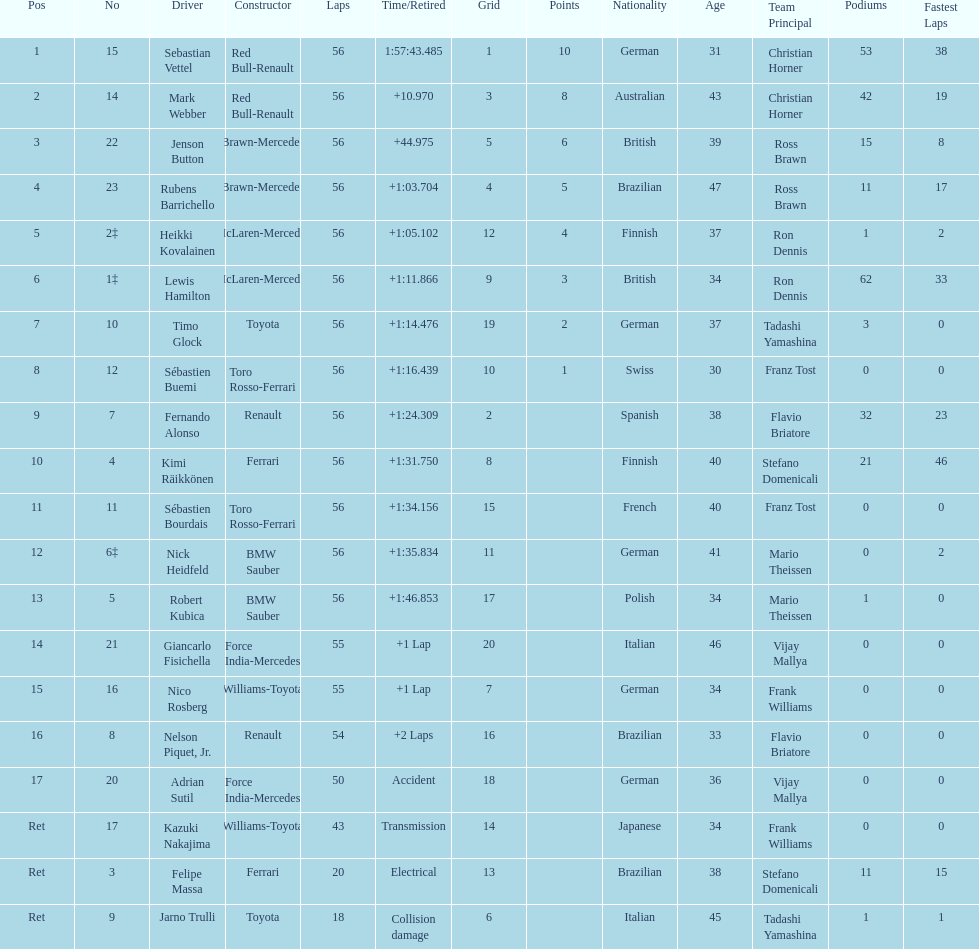What driver was last on the list? Jarno Trulli. 